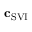<formula> <loc_0><loc_0><loc_500><loc_500>c _ { S V I }</formula> 